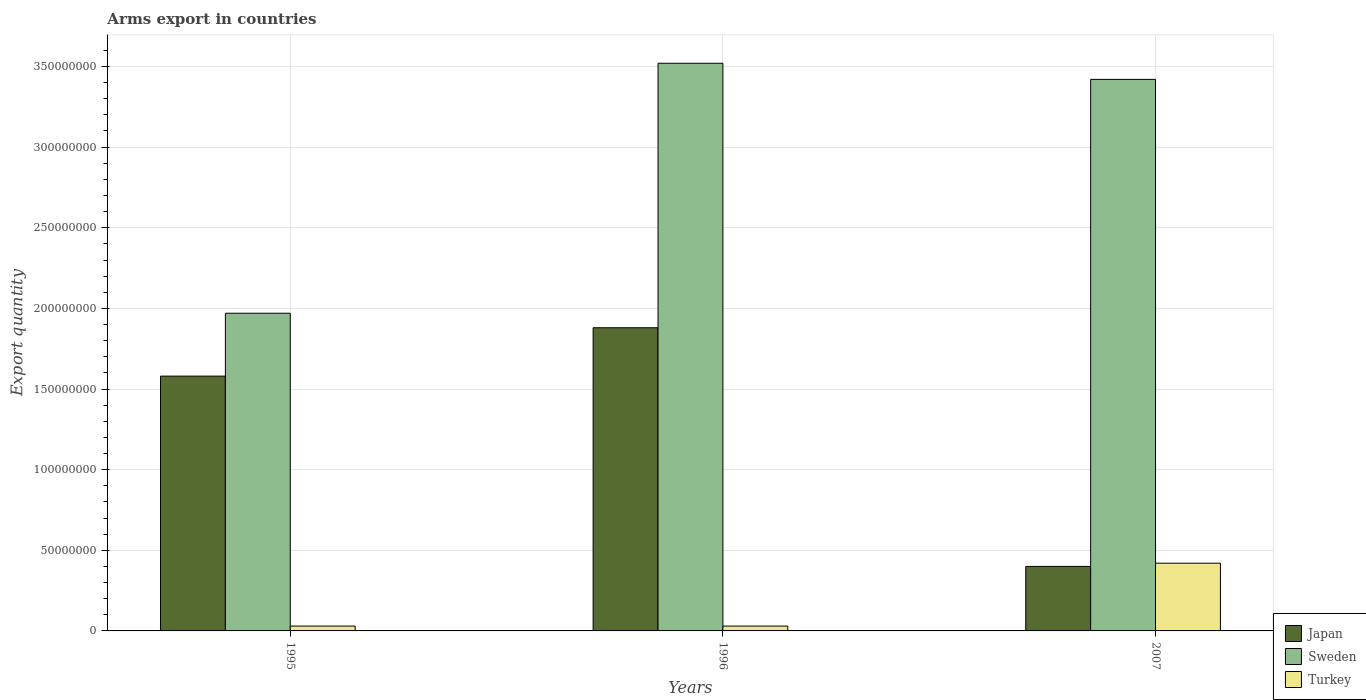How many groups of bars are there?
Offer a very short reply. 3. Are the number of bars per tick equal to the number of legend labels?
Your answer should be very brief. Yes. What is the total arms export in Japan in 1995?
Keep it short and to the point. 1.58e+08. Across all years, what is the maximum total arms export in Sweden?
Keep it short and to the point. 3.52e+08. Across all years, what is the minimum total arms export in Japan?
Your answer should be very brief. 4.00e+07. In which year was the total arms export in Sweden maximum?
Provide a short and direct response. 1996. In which year was the total arms export in Sweden minimum?
Offer a very short reply. 1995. What is the total total arms export in Turkey in the graph?
Provide a succinct answer. 4.80e+07. What is the difference between the total arms export in Japan in 1996 and that in 2007?
Make the answer very short. 1.48e+08. What is the difference between the total arms export in Turkey in 1996 and the total arms export in Sweden in 1995?
Your response must be concise. -1.94e+08. What is the average total arms export in Sweden per year?
Give a very brief answer. 2.97e+08. In the year 1996, what is the difference between the total arms export in Turkey and total arms export in Sweden?
Keep it short and to the point. -3.49e+08. What is the ratio of the total arms export in Sweden in 1995 to that in 1996?
Keep it short and to the point. 0.56. What is the difference between the highest and the second highest total arms export in Japan?
Offer a terse response. 3.00e+07. What is the difference between the highest and the lowest total arms export in Turkey?
Offer a terse response. 3.90e+07. What does the 1st bar from the right in 1996 represents?
Provide a short and direct response. Turkey. Is it the case that in every year, the sum of the total arms export in Turkey and total arms export in Sweden is greater than the total arms export in Japan?
Give a very brief answer. Yes. Are all the bars in the graph horizontal?
Make the answer very short. No. How many years are there in the graph?
Your answer should be compact. 3. What is the difference between two consecutive major ticks on the Y-axis?
Your answer should be compact. 5.00e+07. Does the graph contain grids?
Offer a very short reply. Yes. How are the legend labels stacked?
Provide a succinct answer. Vertical. What is the title of the graph?
Provide a short and direct response. Arms export in countries. Does "Ukraine" appear as one of the legend labels in the graph?
Provide a short and direct response. No. What is the label or title of the Y-axis?
Ensure brevity in your answer.  Export quantity. What is the Export quantity of Japan in 1995?
Your response must be concise. 1.58e+08. What is the Export quantity of Sweden in 1995?
Offer a very short reply. 1.97e+08. What is the Export quantity in Turkey in 1995?
Provide a succinct answer. 3.00e+06. What is the Export quantity in Japan in 1996?
Offer a very short reply. 1.88e+08. What is the Export quantity of Sweden in 1996?
Provide a succinct answer. 3.52e+08. What is the Export quantity of Japan in 2007?
Ensure brevity in your answer.  4.00e+07. What is the Export quantity of Sweden in 2007?
Ensure brevity in your answer.  3.42e+08. What is the Export quantity in Turkey in 2007?
Keep it short and to the point. 4.20e+07. Across all years, what is the maximum Export quantity in Japan?
Ensure brevity in your answer.  1.88e+08. Across all years, what is the maximum Export quantity of Sweden?
Offer a terse response. 3.52e+08. Across all years, what is the maximum Export quantity of Turkey?
Provide a short and direct response. 4.20e+07. Across all years, what is the minimum Export quantity of Japan?
Your response must be concise. 4.00e+07. Across all years, what is the minimum Export quantity in Sweden?
Keep it short and to the point. 1.97e+08. Across all years, what is the minimum Export quantity of Turkey?
Keep it short and to the point. 3.00e+06. What is the total Export quantity in Japan in the graph?
Offer a terse response. 3.86e+08. What is the total Export quantity in Sweden in the graph?
Provide a succinct answer. 8.91e+08. What is the total Export quantity of Turkey in the graph?
Your response must be concise. 4.80e+07. What is the difference between the Export quantity in Japan in 1995 and that in 1996?
Provide a succinct answer. -3.00e+07. What is the difference between the Export quantity in Sweden in 1995 and that in 1996?
Ensure brevity in your answer.  -1.55e+08. What is the difference between the Export quantity of Japan in 1995 and that in 2007?
Offer a terse response. 1.18e+08. What is the difference between the Export quantity in Sweden in 1995 and that in 2007?
Provide a succinct answer. -1.45e+08. What is the difference between the Export quantity in Turkey in 1995 and that in 2007?
Keep it short and to the point. -3.90e+07. What is the difference between the Export quantity of Japan in 1996 and that in 2007?
Make the answer very short. 1.48e+08. What is the difference between the Export quantity in Turkey in 1996 and that in 2007?
Your answer should be very brief. -3.90e+07. What is the difference between the Export quantity in Japan in 1995 and the Export quantity in Sweden in 1996?
Offer a terse response. -1.94e+08. What is the difference between the Export quantity in Japan in 1995 and the Export quantity in Turkey in 1996?
Offer a very short reply. 1.55e+08. What is the difference between the Export quantity in Sweden in 1995 and the Export quantity in Turkey in 1996?
Provide a short and direct response. 1.94e+08. What is the difference between the Export quantity in Japan in 1995 and the Export quantity in Sweden in 2007?
Make the answer very short. -1.84e+08. What is the difference between the Export quantity in Japan in 1995 and the Export quantity in Turkey in 2007?
Your answer should be very brief. 1.16e+08. What is the difference between the Export quantity of Sweden in 1995 and the Export quantity of Turkey in 2007?
Offer a very short reply. 1.55e+08. What is the difference between the Export quantity of Japan in 1996 and the Export quantity of Sweden in 2007?
Offer a very short reply. -1.54e+08. What is the difference between the Export quantity in Japan in 1996 and the Export quantity in Turkey in 2007?
Give a very brief answer. 1.46e+08. What is the difference between the Export quantity in Sweden in 1996 and the Export quantity in Turkey in 2007?
Provide a succinct answer. 3.10e+08. What is the average Export quantity of Japan per year?
Your response must be concise. 1.29e+08. What is the average Export quantity of Sweden per year?
Provide a short and direct response. 2.97e+08. What is the average Export quantity of Turkey per year?
Make the answer very short. 1.60e+07. In the year 1995, what is the difference between the Export quantity in Japan and Export quantity in Sweden?
Your answer should be very brief. -3.90e+07. In the year 1995, what is the difference between the Export quantity of Japan and Export quantity of Turkey?
Make the answer very short. 1.55e+08. In the year 1995, what is the difference between the Export quantity of Sweden and Export quantity of Turkey?
Give a very brief answer. 1.94e+08. In the year 1996, what is the difference between the Export quantity of Japan and Export quantity of Sweden?
Offer a terse response. -1.64e+08. In the year 1996, what is the difference between the Export quantity of Japan and Export quantity of Turkey?
Offer a very short reply. 1.85e+08. In the year 1996, what is the difference between the Export quantity in Sweden and Export quantity in Turkey?
Offer a terse response. 3.49e+08. In the year 2007, what is the difference between the Export quantity of Japan and Export quantity of Sweden?
Ensure brevity in your answer.  -3.02e+08. In the year 2007, what is the difference between the Export quantity of Sweden and Export quantity of Turkey?
Offer a terse response. 3.00e+08. What is the ratio of the Export quantity in Japan in 1995 to that in 1996?
Offer a terse response. 0.84. What is the ratio of the Export quantity in Sweden in 1995 to that in 1996?
Provide a short and direct response. 0.56. What is the ratio of the Export quantity in Turkey in 1995 to that in 1996?
Your response must be concise. 1. What is the ratio of the Export quantity of Japan in 1995 to that in 2007?
Your answer should be compact. 3.95. What is the ratio of the Export quantity of Sweden in 1995 to that in 2007?
Keep it short and to the point. 0.58. What is the ratio of the Export quantity in Turkey in 1995 to that in 2007?
Offer a terse response. 0.07. What is the ratio of the Export quantity in Japan in 1996 to that in 2007?
Keep it short and to the point. 4.7. What is the ratio of the Export quantity of Sweden in 1996 to that in 2007?
Offer a very short reply. 1.03. What is the ratio of the Export quantity in Turkey in 1996 to that in 2007?
Give a very brief answer. 0.07. What is the difference between the highest and the second highest Export quantity in Japan?
Provide a succinct answer. 3.00e+07. What is the difference between the highest and the second highest Export quantity of Turkey?
Ensure brevity in your answer.  3.90e+07. What is the difference between the highest and the lowest Export quantity in Japan?
Give a very brief answer. 1.48e+08. What is the difference between the highest and the lowest Export quantity of Sweden?
Your answer should be very brief. 1.55e+08. What is the difference between the highest and the lowest Export quantity of Turkey?
Make the answer very short. 3.90e+07. 